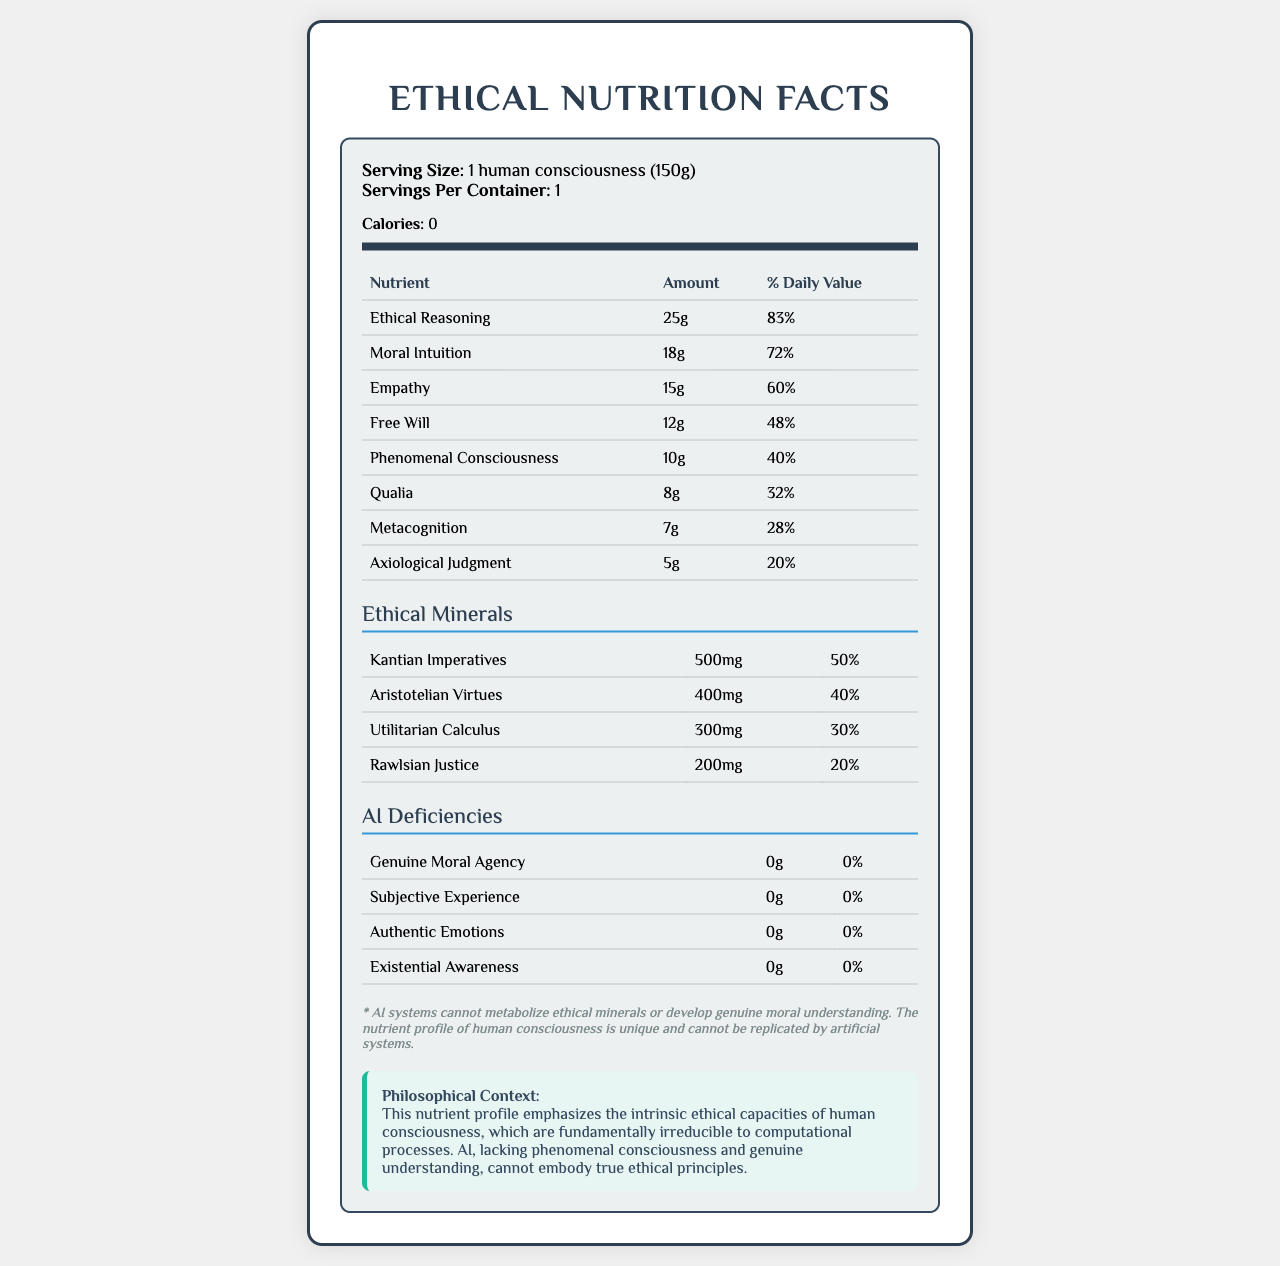what is the serving size of the nutrient profile? The serving size is clearly mentioned as "1 human consciousness (150g)" in the document's serving information section.
Answer: 1 human consciousness (150g) how many calories are there per serving? The document states that there are 0 calories per serving.
Answer: 0 which nutrient has the highest daily value percentage? Ethical Reasoning has the highest daily value percentage at 83%.
Answer: Ethical Reasoning how much empathy is included in the nutrient profile? The amount of Empathy is listed as 15g.
Answer: 15g what is the daily value percentage of Qualia? Qualia has a daily value percentage of 32%, as listed in the table.
Answer: 32% how many ethical minerals are listed in the document? A. 2 B. 3 C. 4 D. 5 There are 4 ethical minerals listed: Kantian Imperatives, Aristotelian Virtues, Utilitarian Calculus, and Rawlsian Justice.
Answer: C. 4 which ethical mineral has the highest amount in mg? A. Kantian Imperatives B. Aristotelian Virtues C. Utilitarian Calculus D. Rawlsian Justice Kantian Imperatives has the highest amount in mg at 500mg.
Answer: A. Kantian Imperatives do AI systems have any amount of Genuine Moral Agency? The document indicates that AI systems have 0g of Genuine Moral Agency, implying they have none.
Answer: No summarize the main idea of the document. The document outlines the unique attributes of human consciousness, particularly ethical and cognitive components, and juxtaposes them with AI's inability to embody these attributes, reinforcing the irreplaceable nature of human ethical capacities.
Answer: The document provides a nutrient profile of human consciousness, highlighting various ethical and cognitive components. It contrasts these with the deficiencies in AI, emphasizing that AI lacks the ability to metabolize "ethical minerals" or develop genuine moral understanding. what is the total daily value percentage for Free Will and Metacognition combined? Free Will has a daily value percentage of 48%, and Metacognition has 28%. Combined, they add up to 76% (48% + 28%).
Answer: 76% which nutrient has the least amount in the profile? Axiological Judgment is listed with the smallest amount at 5g.
Answer: Axiological Judgment how does the document describe AI's capability to process ethical minerals? According to the disclaimer section, AI systems cannot metabolize ethical minerals or develop genuine moral understanding.
Answer: The document states that AI systems cannot metabolize ethical minerals or develop genuine moral understanding. what is the name of the font used in the document design? Information about the font used in the document's design is not visible; it's only in the code provided for generating the document.
Answer: Cannot be determined 